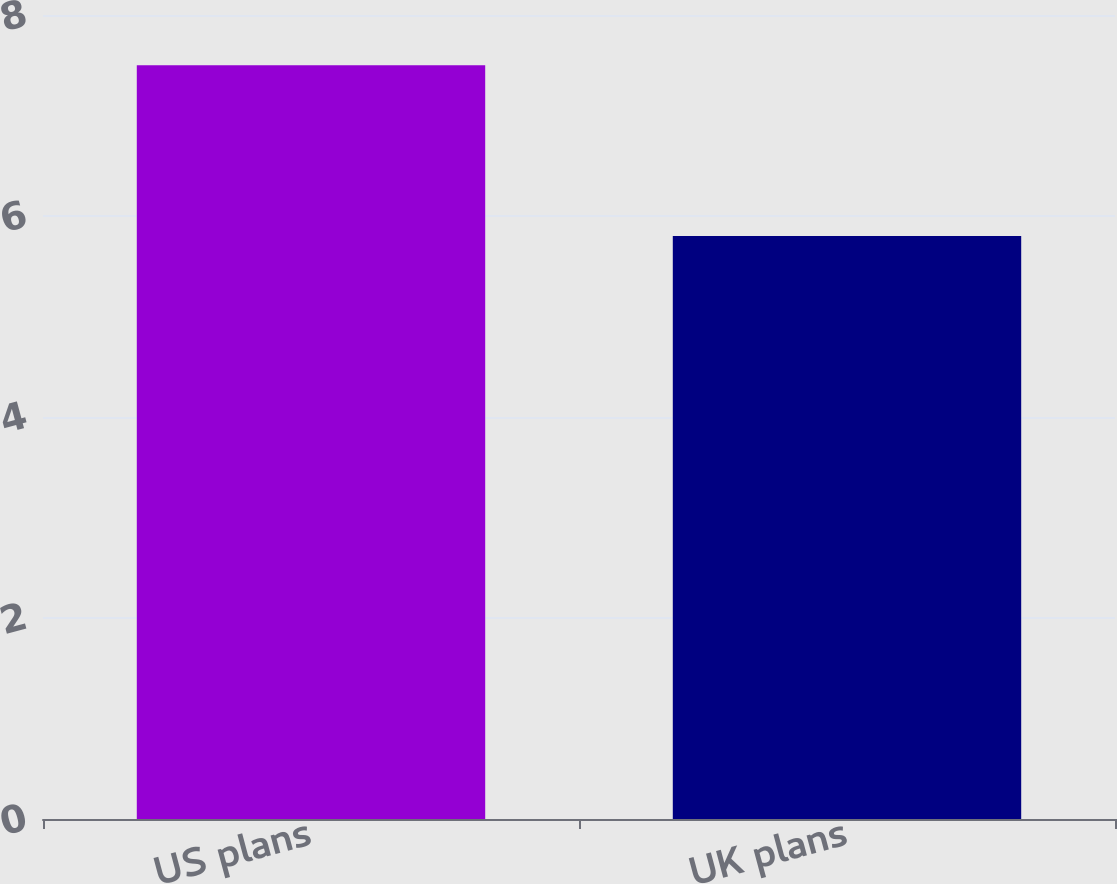Convert chart. <chart><loc_0><loc_0><loc_500><loc_500><bar_chart><fcel>US plans<fcel>UK plans<nl><fcel>7.5<fcel>5.8<nl></chart> 